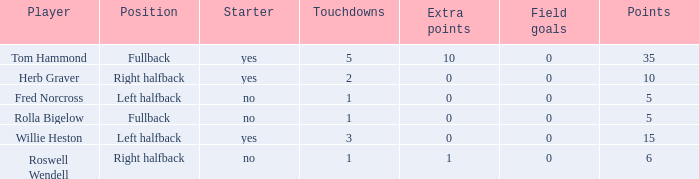What is the lowest number of field goals for a player with 3 touchdowns? 0.0. 